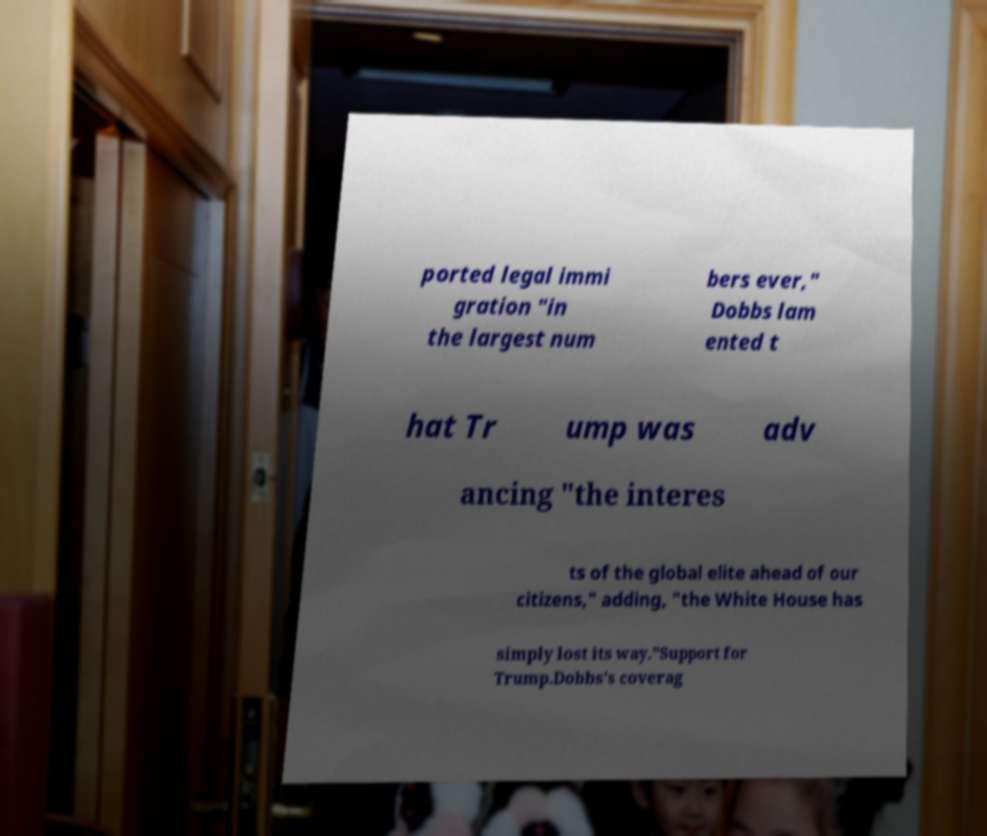Can you accurately transcribe the text from the provided image for me? ported legal immi gration "in the largest num bers ever," Dobbs lam ented t hat Tr ump was adv ancing "the interes ts of the global elite ahead of our citizens," adding, "the White House has simply lost its way."Support for Trump.Dobbs's coverag 